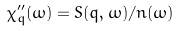Convert formula to latex. <formula><loc_0><loc_0><loc_500><loc_500>\chi ^ { \prime \prime } _ { q } ( \omega ) = S ( q , \omega ) / n ( \omega )</formula> 